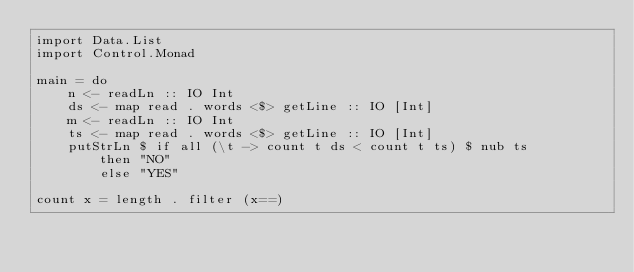Convert code to text. <code><loc_0><loc_0><loc_500><loc_500><_Haskell_>import Data.List
import Control.Monad

main = do
    n <- readLn :: IO Int
    ds <- map read . words <$> getLine :: IO [Int]
    m <- readLn :: IO Int
    ts <- map read . words <$> getLine :: IO [Int]
    putStrLn $ if all (\t -> count t ds < count t ts) $ nub ts
        then "NO"
        else "YES"

count x = length . filter (x==)</code> 